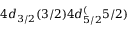Convert formula to latex. <formula><loc_0><loc_0><loc_500><loc_500>4 d _ { 3 / 2 } ( 3 / 2 ) 4 d _ { 5 / 2 } ^ { ( } 5 / 2 )</formula> 